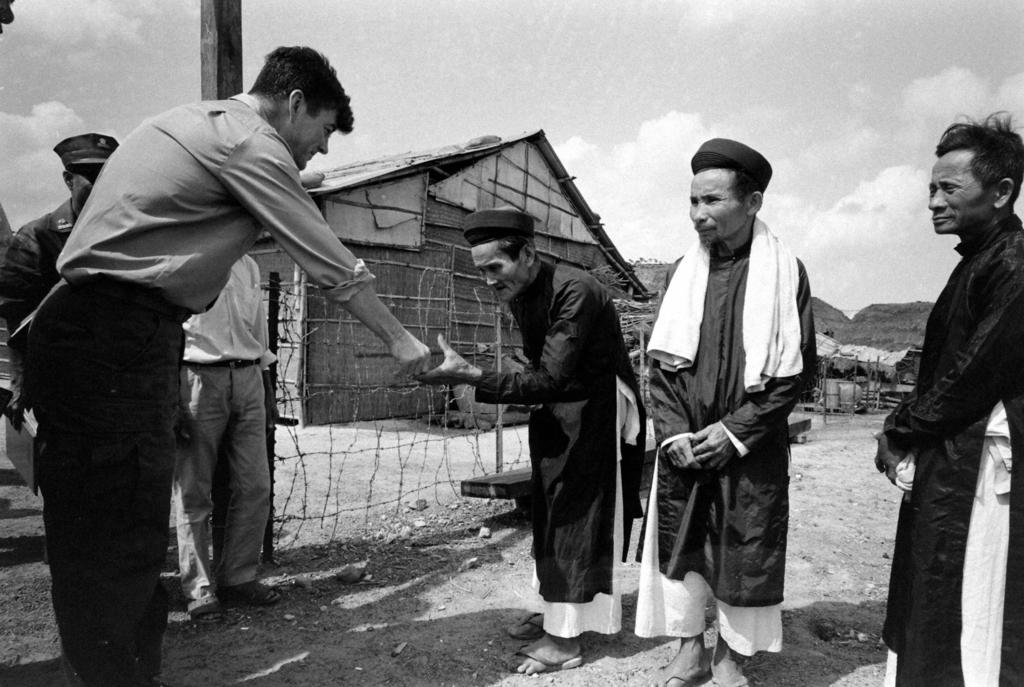How many people are in the image? There are persons in the image, but the exact number is not specified. What is the fence used for in the image? The purpose of the fence in the image is not clear, but it could be used for enclosing an area or providing a boundary. What type of structures are present in the image? There are huts in the image, which could be used for shelter or living spaces. What is the pole used for in the image? The purpose of the pole in the image is not clear, but it could be used for supporting a structure or hanging items. What can be seen in the background of the image? The sky with clouds is visible in the background of the image, indicating the presence of a clear sky or a partly cloudy day. What type of bubble can be seen floating in the image? There is no bubble present in the image. What is the taste of the sleet falling in the image? There is no sleet present in the image, so it is not possible to determine its taste. 